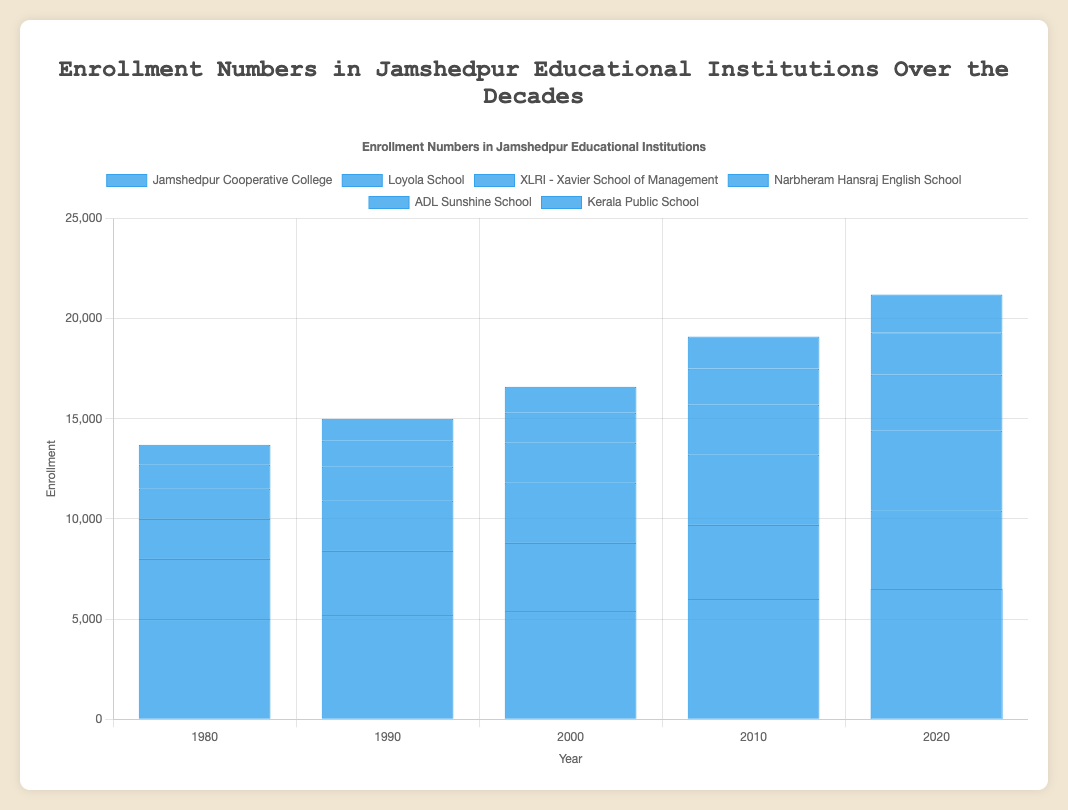Which institution had the highest enrollment in 2020? Look at the bar corresponding to the year 2020 and compare the height of the bars for each institution. The tallest bar indicates the highest enrollment.
Answer: Jamshedpur Cooperative College Which school showed the least increase in enrollment from 1980 to 2020? Calculate the difference in enrollment numbers from 1980 to 2020 for each institution and compare these values. ADL Sunshine School had the smallest difference (2100 - 1200 = 900).
Answer: ADL Sunshine School What is the combined enrollment of Loyola School and XLRI - Xavier School of Management in 2010? Look at the bars for Loyola School and XLRI - Xavier School of Management in the year 2010 and add their enrollments (3700 + 3500).
Answer: 7200 Which institution had a steady increase in enrollment from 1980 to 2020? Compare the bars of each institution across the decades; an institution with a visually consistent upward trend in bar height has a steady increase.
Answer: Loyola School What was the enrollment of Kerala Public School in 1980 and 2020? By what factor did the enrollment increase over these 40 years? Note the enrollment numbers of Kerala Public School for the years 1980 and 2020 (1000 and 1900, respectively). Calculate the factor of increase (1900/1000).
Answer: 1.9 Which year showed the highest growth in enrollment for Jamshedpur Cooperative College compared to the previous decade? Calculate the difference in enrollment numbers for Jamshedpur Cooperative College for consecutive decades and determine the maximum increase (6000 - 5400 in 2010).
Answer: 2010 Which institution had the smallest difference in enrollment between 2010 and 2020? Calculate the difference in enrollment numbers for each institution between 2010 and 2020, checking for the minimum difference. Narbheram Hansraj English School had the smallest difference (2800 - 2500 = 300).
Answer: Narbheram Hansraj English School What is the average enrollment across all institutions in 1990? Sum up the enrollment numbers for all institutions in 1990 and divide by the number of institutions (5200 + 3200 + 2500 + 1700 + 1300 + 1100) / 6.
Answer: 2500 Compare the enrollments for Loyola School and Narbheram Hansraj English School in 2020. Which one is higher, and by how much? Note the enrollment numbers for both schools in 2020 (Loyola School: 3900, Narbheram Hansraj English School: 2800) and find the difference.
Answer: Loyola School, by 1100 